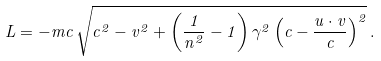Convert formula to latex. <formula><loc_0><loc_0><loc_500><loc_500>L = - m c \, \sqrt { c ^ { 2 } - v ^ { 2 } + \left ( \frac { 1 } { n ^ { 2 } } - 1 \right ) \gamma ^ { 2 } \left ( c - \frac { { u } \cdot { v } } { c } \right ) ^ { 2 } } \, .</formula> 